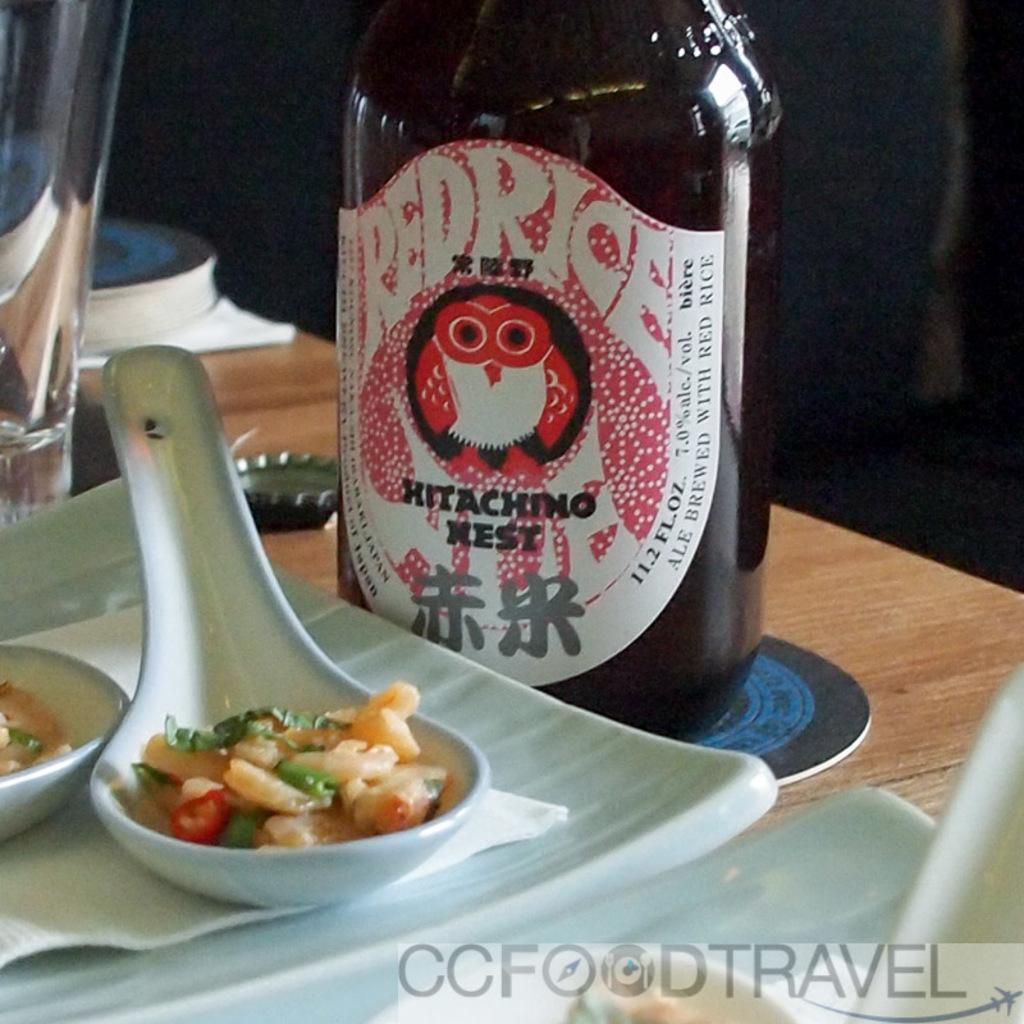<image>
Write a terse but informative summary of the picture. The Red Rice Hitaching Nest beer is served next to some soup. 